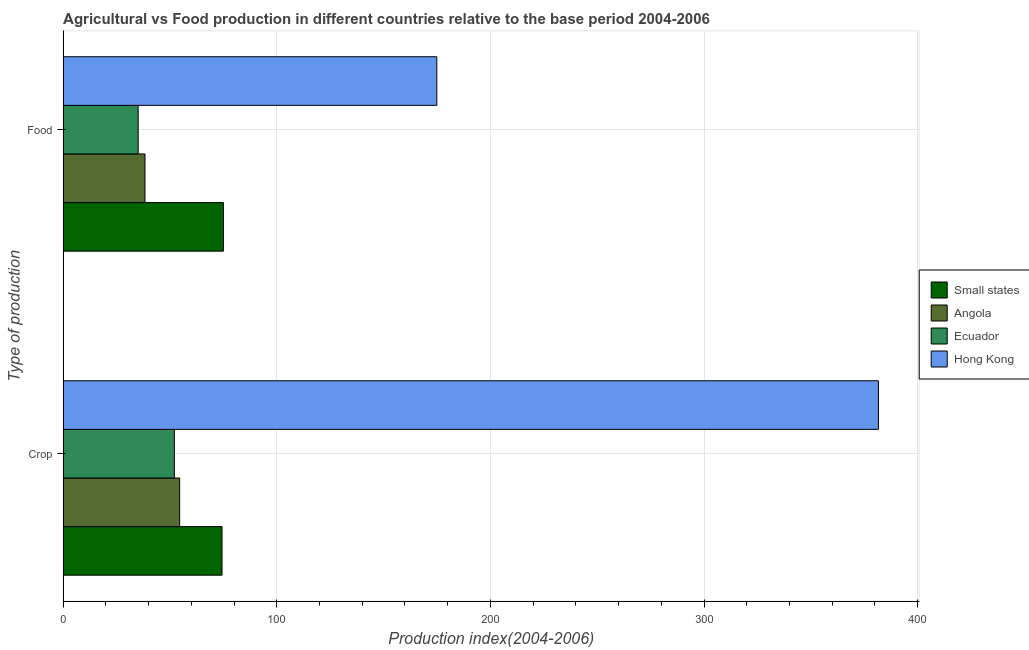How many different coloured bars are there?
Your answer should be compact. 4. How many groups of bars are there?
Your response must be concise. 2. Are the number of bars on each tick of the Y-axis equal?
Your response must be concise. Yes. How many bars are there on the 1st tick from the top?
Offer a very short reply. 4. How many bars are there on the 2nd tick from the bottom?
Ensure brevity in your answer.  4. What is the label of the 2nd group of bars from the top?
Your response must be concise. Crop. What is the crop production index in Small states?
Give a very brief answer. 74.34. Across all countries, what is the maximum crop production index?
Ensure brevity in your answer.  381.67. Across all countries, what is the minimum crop production index?
Offer a very short reply. 52.03. In which country was the food production index maximum?
Ensure brevity in your answer.  Hong Kong. In which country was the food production index minimum?
Ensure brevity in your answer.  Ecuador. What is the total crop production index in the graph?
Provide a short and direct response. 562.55. What is the difference between the food production index in Small states and that in Angola?
Provide a short and direct response. 36.7. What is the difference between the food production index in Small states and the crop production index in Ecuador?
Provide a short and direct response. 22.95. What is the average food production index per country?
Ensure brevity in your answer.  80.81. What is the difference between the food production index and crop production index in Small states?
Provide a succinct answer. 0.64. In how many countries, is the crop production index greater than 40 ?
Your answer should be compact. 4. What is the ratio of the food production index in Hong Kong to that in Ecuador?
Keep it short and to the point. 4.99. Is the crop production index in Angola less than that in Ecuador?
Your answer should be very brief. No. In how many countries, is the crop production index greater than the average crop production index taken over all countries?
Give a very brief answer. 1. What does the 3rd bar from the top in Food represents?
Give a very brief answer. Angola. What does the 2nd bar from the bottom in Crop represents?
Your answer should be very brief. Angola. What is the difference between two consecutive major ticks on the X-axis?
Your response must be concise. 100. Does the graph contain any zero values?
Provide a short and direct response. No. Where does the legend appear in the graph?
Your answer should be very brief. Center right. How many legend labels are there?
Your answer should be compact. 4. How are the legend labels stacked?
Give a very brief answer. Vertical. What is the title of the graph?
Your answer should be very brief. Agricultural vs Food production in different countries relative to the base period 2004-2006. What is the label or title of the X-axis?
Keep it short and to the point. Production index(2004-2006). What is the label or title of the Y-axis?
Give a very brief answer. Type of production. What is the Production index(2004-2006) in Small states in Crop?
Your answer should be very brief. 74.34. What is the Production index(2004-2006) of Angola in Crop?
Your answer should be compact. 54.51. What is the Production index(2004-2006) of Ecuador in Crop?
Provide a succinct answer. 52.03. What is the Production index(2004-2006) of Hong Kong in Crop?
Your response must be concise. 381.67. What is the Production index(2004-2006) in Small states in Food?
Offer a very short reply. 74.98. What is the Production index(2004-2006) in Angola in Food?
Your response must be concise. 38.28. What is the Production index(2004-2006) of Ecuador in Food?
Your answer should be compact. 35.08. What is the Production index(2004-2006) of Hong Kong in Food?
Give a very brief answer. 174.9. Across all Type of production, what is the maximum Production index(2004-2006) of Small states?
Your response must be concise. 74.98. Across all Type of production, what is the maximum Production index(2004-2006) of Angola?
Offer a very short reply. 54.51. Across all Type of production, what is the maximum Production index(2004-2006) in Ecuador?
Your answer should be very brief. 52.03. Across all Type of production, what is the maximum Production index(2004-2006) in Hong Kong?
Your answer should be very brief. 381.67. Across all Type of production, what is the minimum Production index(2004-2006) of Small states?
Your answer should be very brief. 74.34. Across all Type of production, what is the minimum Production index(2004-2006) in Angola?
Provide a short and direct response. 38.28. Across all Type of production, what is the minimum Production index(2004-2006) in Ecuador?
Ensure brevity in your answer.  35.08. Across all Type of production, what is the minimum Production index(2004-2006) of Hong Kong?
Offer a very short reply. 174.9. What is the total Production index(2004-2006) in Small states in the graph?
Your response must be concise. 149.32. What is the total Production index(2004-2006) of Angola in the graph?
Your response must be concise. 92.79. What is the total Production index(2004-2006) of Ecuador in the graph?
Keep it short and to the point. 87.11. What is the total Production index(2004-2006) of Hong Kong in the graph?
Provide a succinct answer. 556.57. What is the difference between the Production index(2004-2006) in Small states in Crop and that in Food?
Offer a very short reply. -0.64. What is the difference between the Production index(2004-2006) in Angola in Crop and that in Food?
Offer a terse response. 16.23. What is the difference between the Production index(2004-2006) in Ecuador in Crop and that in Food?
Give a very brief answer. 16.95. What is the difference between the Production index(2004-2006) in Hong Kong in Crop and that in Food?
Provide a succinct answer. 206.77. What is the difference between the Production index(2004-2006) in Small states in Crop and the Production index(2004-2006) in Angola in Food?
Your response must be concise. 36.06. What is the difference between the Production index(2004-2006) in Small states in Crop and the Production index(2004-2006) in Ecuador in Food?
Give a very brief answer. 39.26. What is the difference between the Production index(2004-2006) in Small states in Crop and the Production index(2004-2006) in Hong Kong in Food?
Give a very brief answer. -100.56. What is the difference between the Production index(2004-2006) in Angola in Crop and the Production index(2004-2006) in Ecuador in Food?
Your response must be concise. 19.43. What is the difference between the Production index(2004-2006) in Angola in Crop and the Production index(2004-2006) in Hong Kong in Food?
Your answer should be compact. -120.39. What is the difference between the Production index(2004-2006) of Ecuador in Crop and the Production index(2004-2006) of Hong Kong in Food?
Your response must be concise. -122.87. What is the average Production index(2004-2006) in Small states per Type of production?
Your answer should be compact. 74.66. What is the average Production index(2004-2006) of Angola per Type of production?
Your response must be concise. 46.4. What is the average Production index(2004-2006) in Ecuador per Type of production?
Your answer should be compact. 43.55. What is the average Production index(2004-2006) in Hong Kong per Type of production?
Provide a short and direct response. 278.29. What is the difference between the Production index(2004-2006) in Small states and Production index(2004-2006) in Angola in Crop?
Offer a very short reply. 19.83. What is the difference between the Production index(2004-2006) in Small states and Production index(2004-2006) in Ecuador in Crop?
Your response must be concise. 22.31. What is the difference between the Production index(2004-2006) of Small states and Production index(2004-2006) of Hong Kong in Crop?
Offer a terse response. -307.33. What is the difference between the Production index(2004-2006) of Angola and Production index(2004-2006) of Ecuador in Crop?
Provide a succinct answer. 2.48. What is the difference between the Production index(2004-2006) of Angola and Production index(2004-2006) of Hong Kong in Crop?
Your answer should be compact. -327.16. What is the difference between the Production index(2004-2006) in Ecuador and Production index(2004-2006) in Hong Kong in Crop?
Ensure brevity in your answer.  -329.64. What is the difference between the Production index(2004-2006) in Small states and Production index(2004-2006) in Angola in Food?
Provide a succinct answer. 36.7. What is the difference between the Production index(2004-2006) of Small states and Production index(2004-2006) of Ecuador in Food?
Give a very brief answer. 39.9. What is the difference between the Production index(2004-2006) of Small states and Production index(2004-2006) of Hong Kong in Food?
Your answer should be compact. -99.92. What is the difference between the Production index(2004-2006) in Angola and Production index(2004-2006) in Ecuador in Food?
Ensure brevity in your answer.  3.2. What is the difference between the Production index(2004-2006) of Angola and Production index(2004-2006) of Hong Kong in Food?
Ensure brevity in your answer.  -136.62. What is the difference between the Production index(2004-2006) of Ecuador and Production index(2004-2006) of Hong Kong in Food?
Provide a short and direct response. -139.82. What is the ratio of the Production index(2004-2006) of Small states in Crop to that in Food?
Keep it short and to the point. 0.99. What is the ratio of the Production index(2004-2006) of Angola in Crop to that in Food?
Make the answer very short. 1.42. What is the ratio of the Production index(2004-2006) of Ecuador in Crop to that in Food?
Offer a terse response. 1.48. What is the ratio of the Production index(2004-2006) in Hong Kong in Crop to that in Food?
Your answer should be very brief. 2.18. What is the difference between the highest and the second highest Production index(2004-2006) in Small states?
Keep it short and to the point. 0.64. What is the difference between the highest and the second highest Production index(2004-2006) in Angola?
Provide a succinct answer. 16.23. What is the difference between the highest and the second highest Production index(2004-2006) in Ecuador?
Your response must be concise. 16.95. What is the difference between the highest and the second highest Production index(2004-2006) in Hong Kong?
Your answer should be compact. 206.77. What is the difference between the highest and the lowest Production index(2004-2006) of Small states?
Your answer should be compact. 0.64. What is the difference between the highest and the lowest Production index(2004-2006) in Angola?
Your answer should be very brief. 16.23. What is the difference between the highest and the lowest Production index(2004-2006) of Ecuador?
Keep it short and to the point. 16.95. What is the difference between the highest and the lowest Production index(2004-2006) of Hong Kong?
Give a very brief answer. 206.77. 